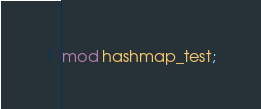Convert code to text. <code><loc_0><loc_0><loc_500><loc_500><_Rust_>mod hashmap_test;</code> 